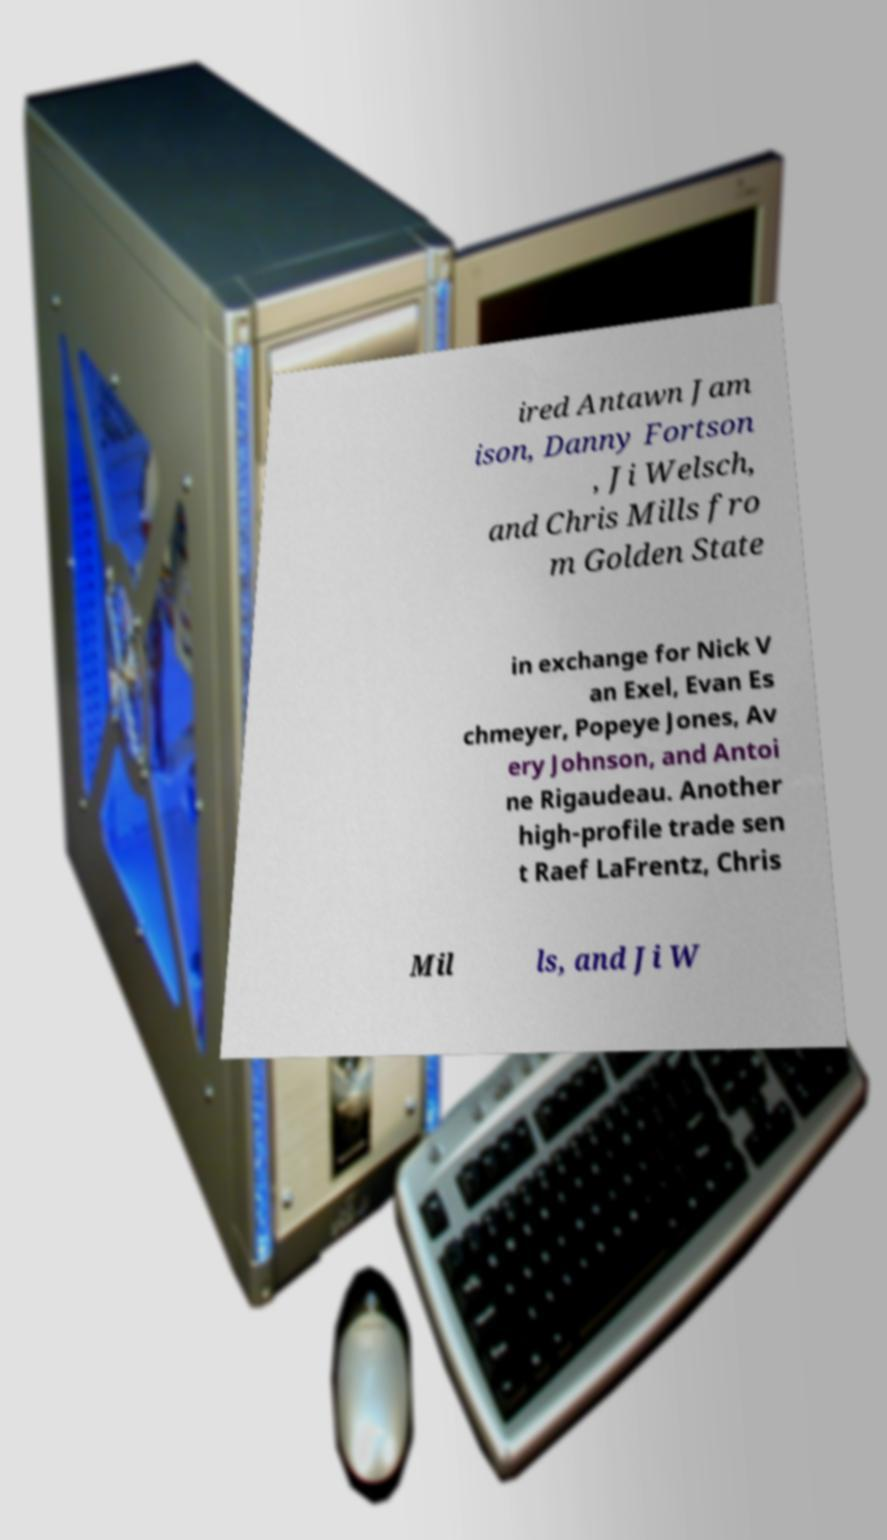Could you extract and type out the text from this image? ired Antawn Jam ison, Danny Fortson , Ji Welsch, and Chris Mills fro m Golden State in exchange for Nick V an Exel, Evan Es chmeyer, Popeye Jones, Av ery Johnson, and Antoi ne Rigaudeau. Another high-profile trade sen t Raef LaFrentz, Chris Mil ls, and Ji W 